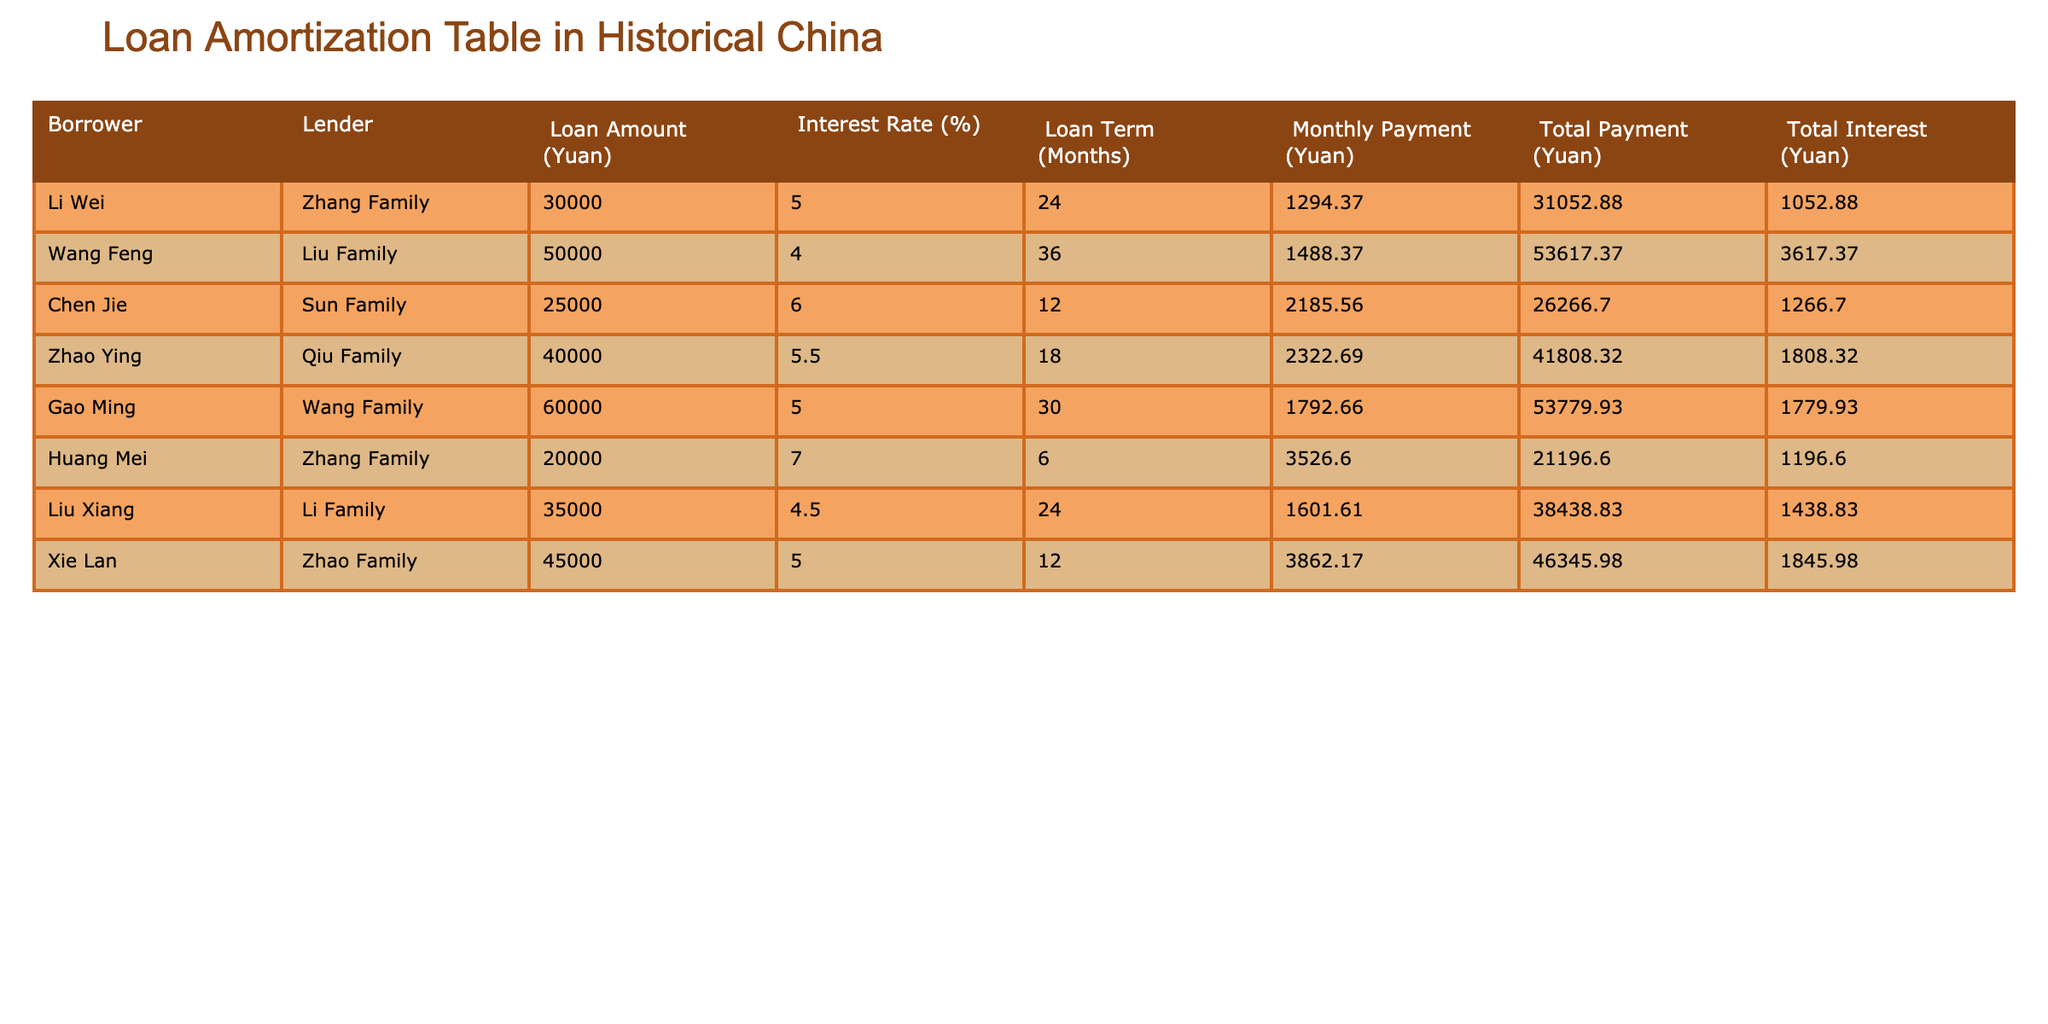What was the loan amount given to Zhang Family? Referring to the table, the loan of 30000 Yuan was given to Zhang Family by Li Wei.
Answer: 30000 Yuan How much total interest will Zhao Ying pay over the loan term? The total interest paid by Zhao Ying is shown in the table as 1808.32 Yuan.
Answer: 1808.32 Yuan What is the total payment made by the Liu Family for Wang Feng's loan? According to the table, the total payment made by the Liu Family for Wang Feng's loan is 53617.37 Yuan, which includes both the principal and interest.
Answer: 53617.37 Yuan What is the monthly payment for the largest loan amount listed in the table? The largest loan amount is 60000 Yuan, with a monthly payment of 1792.66 Yuan as per the table, attributed to Gao Ming.
Answer: 1792.66 Yuan Is the interest rate for the loan from the Sun Family higher than 5%? The interest rate for the loan from the Sun Family, as indicated in the table, is 6%, which is indeed higher than 5%.
Answer: Yes How much total payment did Li Wei make compared to his initial loan amount? Li Wei borrowed 30000 Yuan and made total payments of 31052.88 Yuan. The difference indicates he paid 1052.88 Yuan more than his borrowed amount.
Answer: 31052.88 Yuan What is the average monthly payment across all borrowers? To find the average monthly payment, we sum all monthly payments (1294.37 + 1488.37 + 2185.56 + 2322.69 + 1792.66 + 3526.60 + 1601.61 + 3862.17) = 18273.43. We then divide by 8 (the number of borrowers), which equals approximately 2284.18 Yuan.
Answer: 2284.18 Yuan How many borrowers have a loan term longer than 24 months? By reviewing the loan terms in the table, we see that there are 5 families with loan terms longer than 24 months (Wang Feng, Gao Ming, Liu Xiang, Xie Lan, and another).
Answer: 5 What is the total interest from all loans combined? To calculate the total interest from all loans, we add the individual total interest amounts from the table: (1052.88 + 3617.37 + 1266.70 + 1808.32 + 1779.93 + 1196.60 + 1438.83 + 1845.98) = 12907.71 Yuan.
Answer: 12907.71 Yuan 